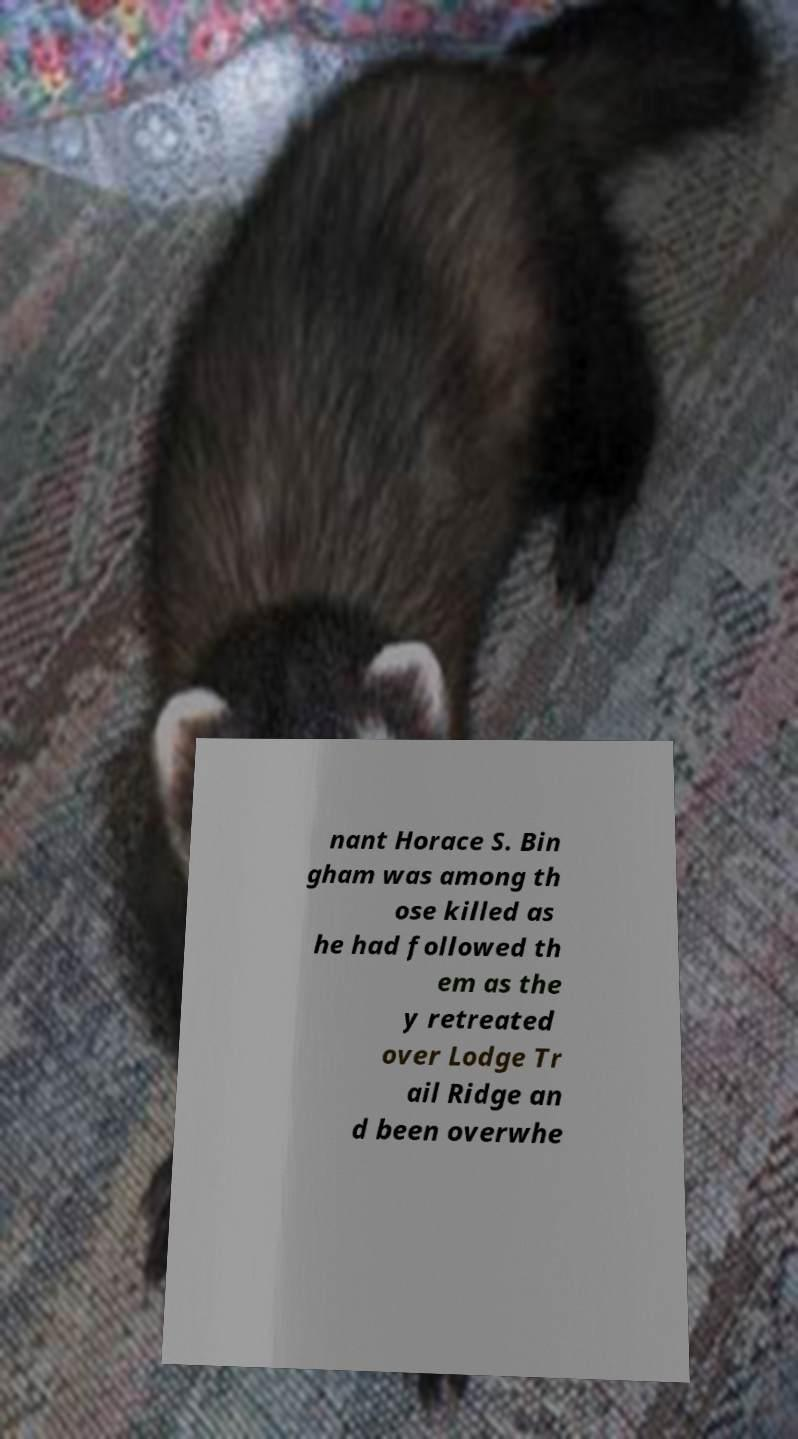I need the written content from this picture converted into text. Can you do that? nant Horace S. Bin gham was among th ose killed as he had followed th em as the y retreated over Lodge Tr ail Ridge an d been overwhe 